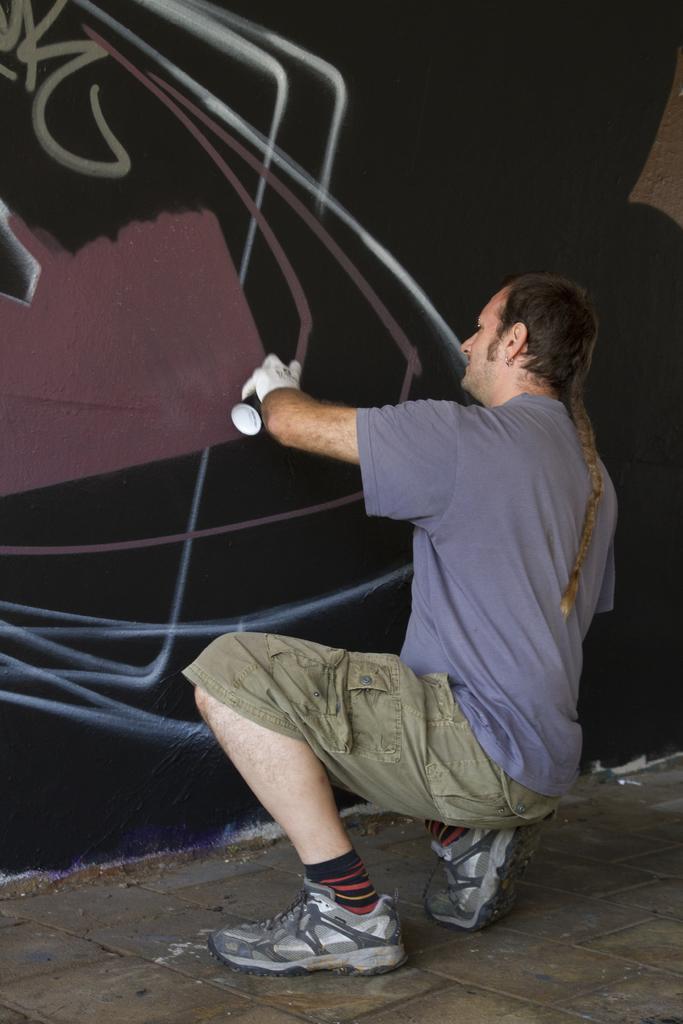What is the man in the image doing? The man is in a crouch position on the floor. What is the man holding in his hand? The man is holding a spray bottle in his hand. What can be seen on the wall in the image? There are drawings on the wall in the image. What verse is the man reciting in the image? There is no indication in the image that the man is reciting a verse, so it cannot be determined from the picture. 